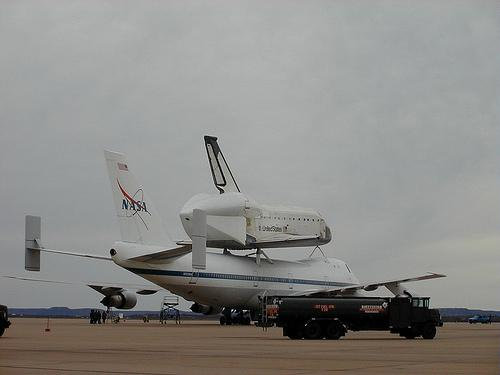Choose three objects in the image and describe their colors. A long black truck, a blue truck in the distance, and an orange safety marker. What is happening under the wing of the airplane? People are standing under the wing, and there's a platform and railing present as well. What is unique about the airplane in the image? The airplane carries a shuttle with a tall black wing and bears the NASA symbol on its body. Write a brief description of the scene in the image. A shuttle on an airplane surrounded by trucks, people, and airplane equipment in a spacious airfield with a vast sky above. Describe the weather conditions in the image. Bright and clear sky, providing ideal conditions for aviation activities. Write a sentence describing the tail of the airplane. The airplane's tail features a black and white rectangle and the logo of an aeronautics organization. Mention the most dominant feature in the image. Shuttle riding piggyback on an airplane in a wide sky backdrop. 